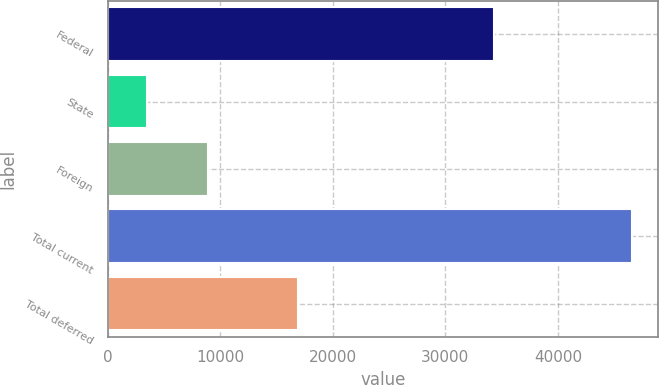<chart> <loc_0><loc_0><loc_500><loc_500><bar_chart><fcel>Federal<fcel>State<fcel>Foreign<fcel>Total current<fcel>Total deferred<nl><fcel>34320<fcel>3436<fcel>8858<fcel>46614<fcel>16869<nl></chart> 